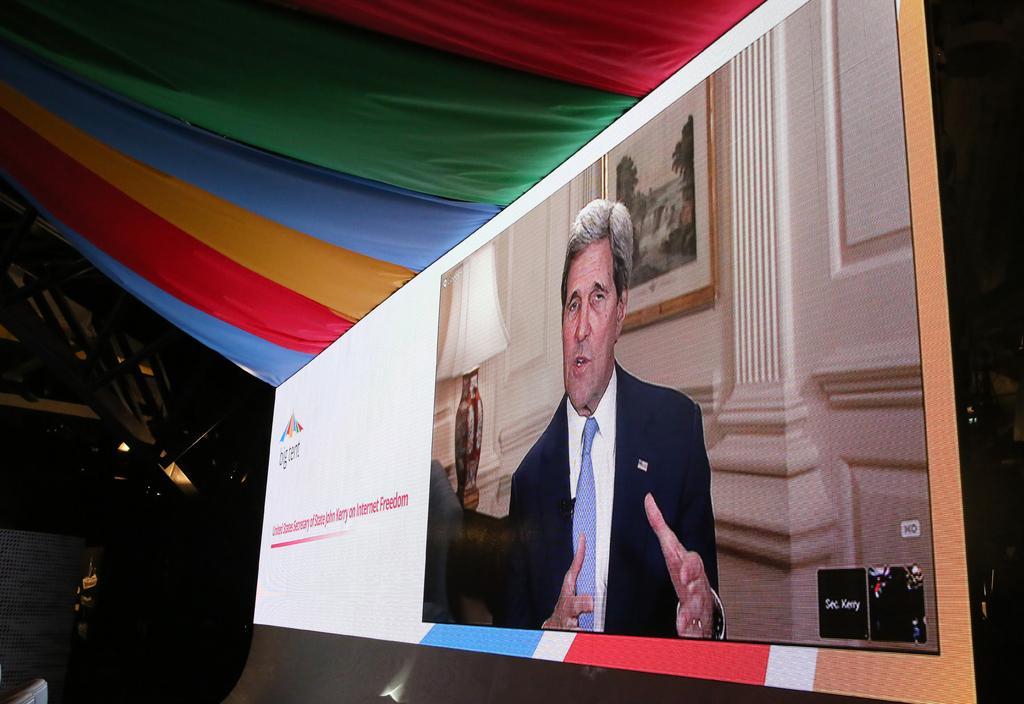Could you give a brief overview of what you see in this image? In this image we can see a projector screen on which there is some video is telecasting, at the top of the image there are some different colors of clothes and at the background of the image there is black color sheet. 